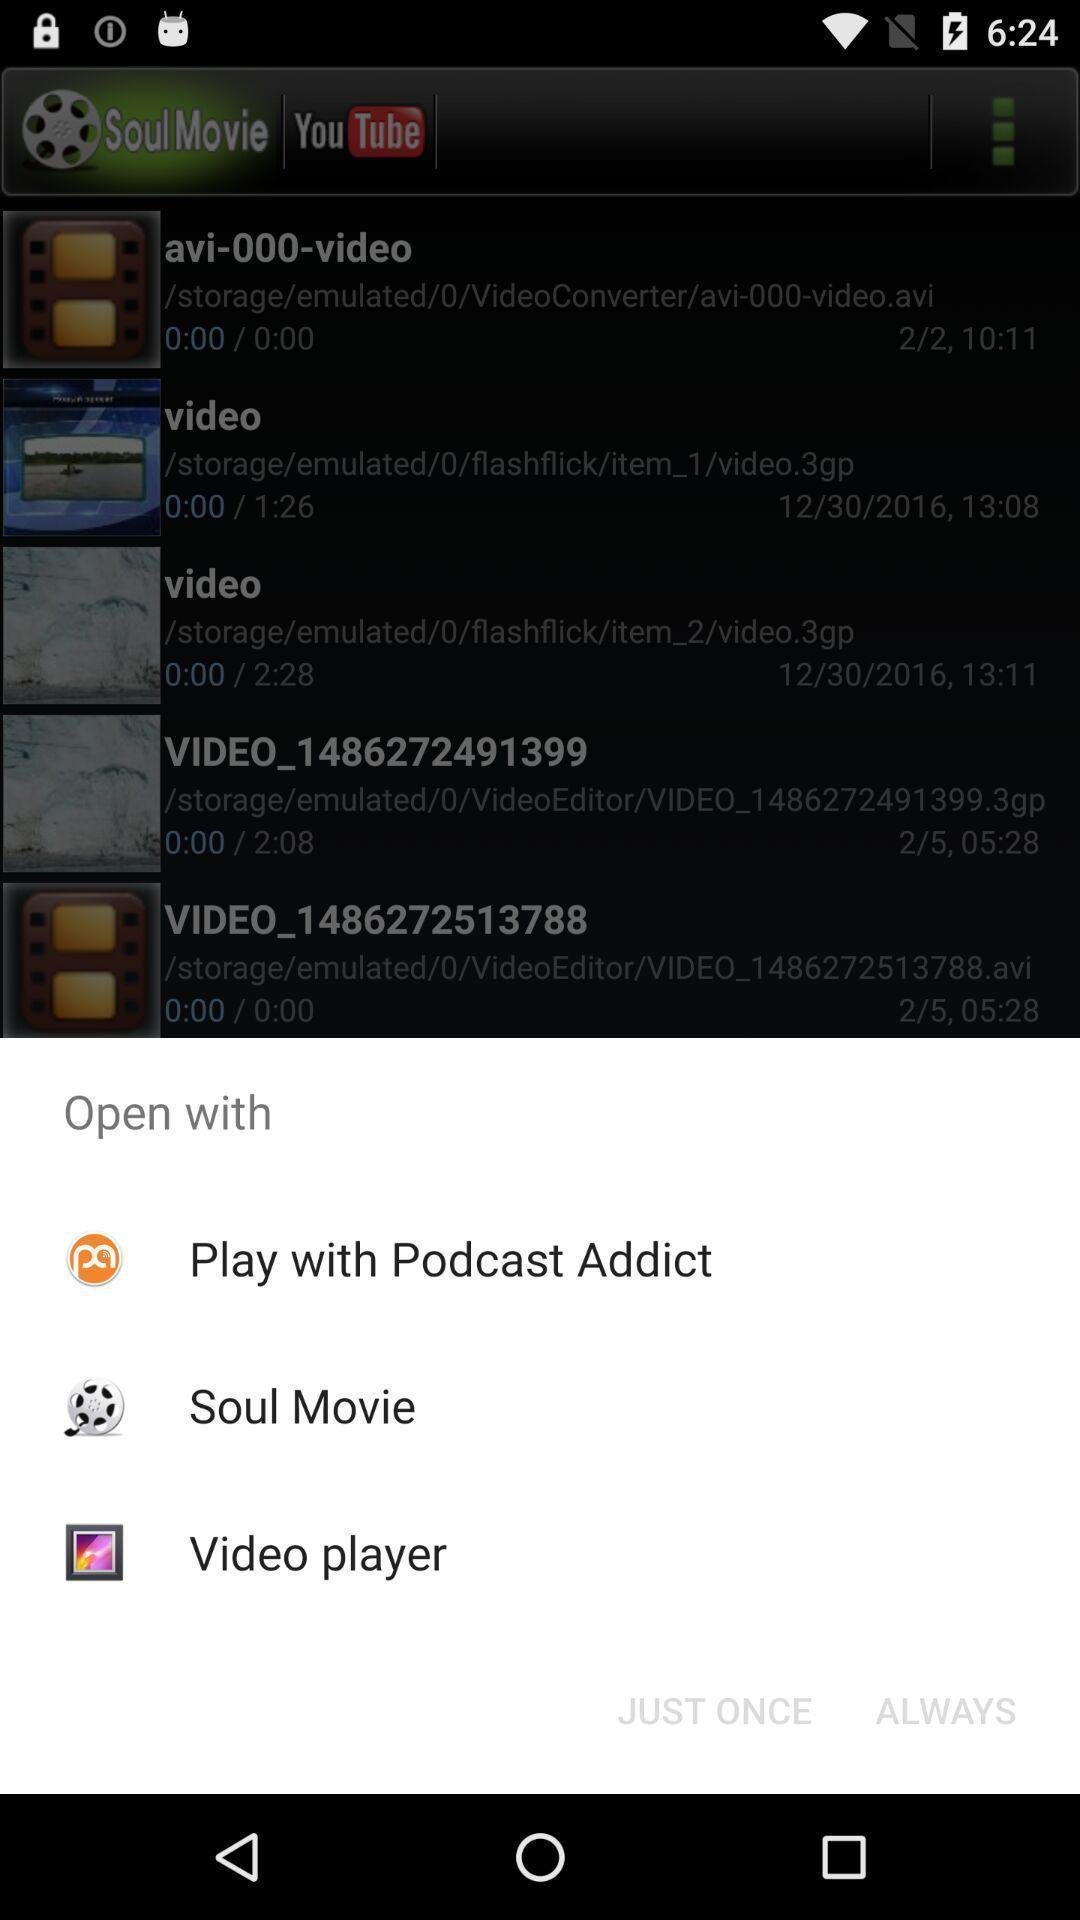What can you discern from this picture? Popup to open in the video streaming app. 